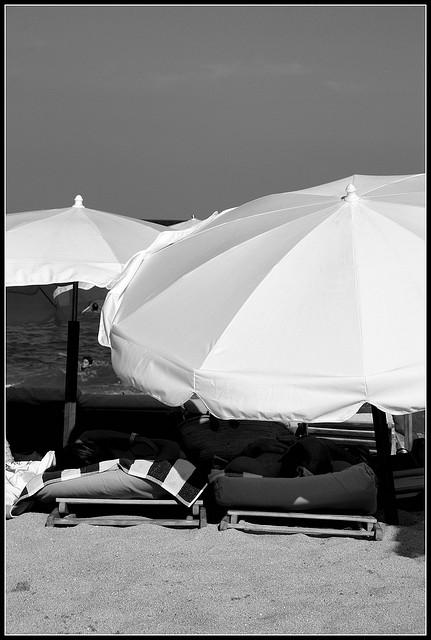Does this large white item lesson one's need for sunscreen?
Concise answer only. Yes. How can you tell if the sun is out in this photo?
Be succinct. Shadows. Is this at the beach?
Quick response, please. Yes. 